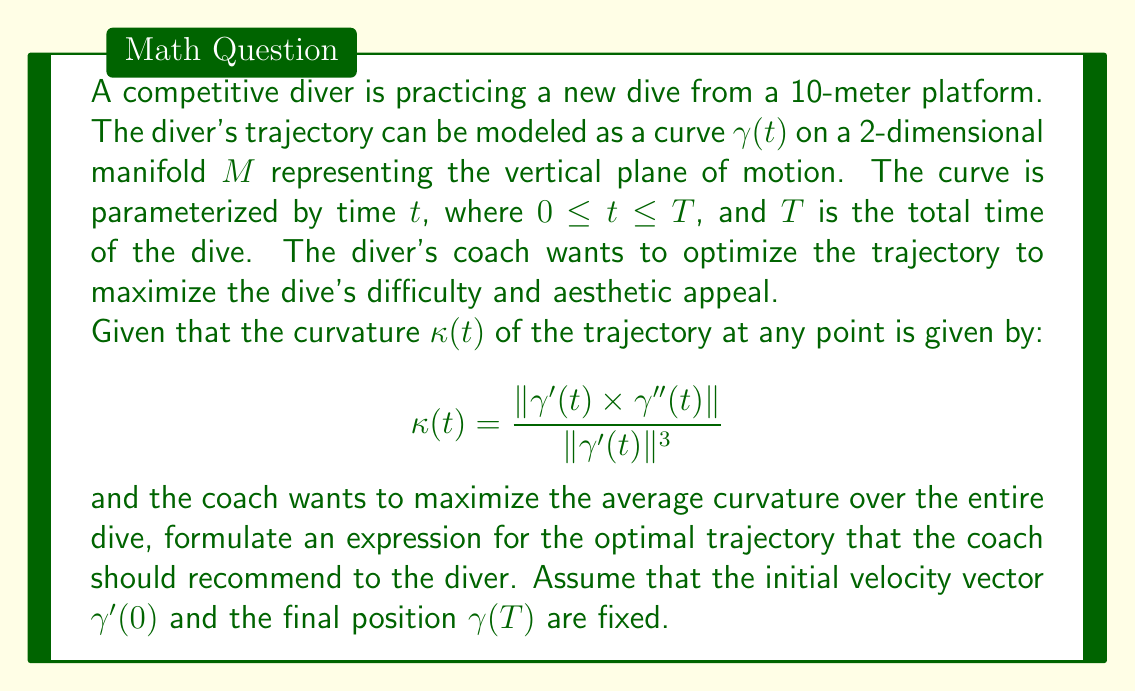Provide a solution to this math problem. To optimize the trajectory of the dive using differential geometry, we need to consider the following steps:

1) The average curvature over the entire dive can be expressed as:

   $$\bar{\kappa} = \frac{1}{T} \int_0^T \kappa(t) dt$$

2) Substituting the given curvature formula:

   $$\bar{\kappa} = \frac{1}{T} \int_0^T \frac{\|\gamma'(t) \times \gamma''(t)\|}{\|\gamma'(t)\|^3} dt$$

3) To maximize this, we can use the calculus of variations. We need to find the curve $\gamma(t)$ that maximizes this integral subject to the given constraints.

4) The Euler-Lagrange equation for this variational problem is:

   $$\frac{d}{dt}\left(\frac{\partial L}{\partial \gamma'}\right) - \frac{\partial L}{\partial \gamma} = 0$$

   where $L = \frac{\|\gamma'(t) \times \gamma''(t)\|}{\|\gamma'(t)\|^3}$

5) Solving this equation analytically is complex, but it leads to a differential equation that the optimal trajectory must satisfy.

6) In practice, numerical methods would be used to solve this equation, subject to the boundary conditions:

   $\gamma(0) = (0, 10)$ (starting at the 10m platform)
   $\gamma'(0) = $ given initial velocity
   $\gamma(T) = $ given final position

7) The resulting trajectory $\gamma(t)$ would be a curve that maximizes the average curvature, potentially leading to a more difficult and aesthetically pleasing dive.

8) The coach should recommend this trajectory to the diver, possibly by breaking it down into key positions or moments during the dive that the diver should aim for.
Answer: The optimal trajectory $\gamma(t)$ should satisfy the Euler-Lagrange equation:

$$\frac{d}{dt}\left(\frac{\partial}{\partial \gamma'}\left(\frac{\|\gamma'(t) \times \gamma''(t)\|}{\|\gamma'(t)\|^3}\right)\right) - \frac{\partial}{\partial \gamma}\left(\frac{\|\gamma'(t) \times \gamma''(t)\|}{\|\gamma'(t)\|^3}\right) = 0$$

subject to the boundary conditions:
$\gamma(0) = (0, 10)$
$\gamma'(0) = $ given initial velocity
$\gamma(T) = $ given final position

The exact solution would require numerical methods to solve this differential equation. 